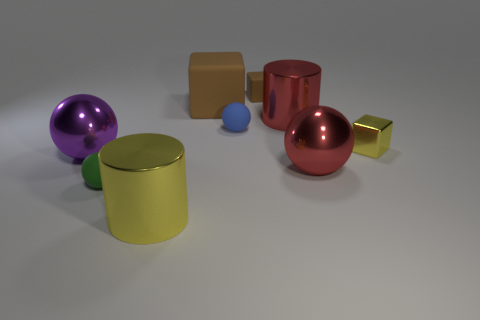What number of small green matte spheres are in front of the small yellow thing?
Keep it short and to the point. 1. The purple shiny object that is the same shape as the green thing is what size?
Make the answer very short. Large. What number of yellow things are either big cylinders or big blocks?
Keep it short and to the point. 1. How many tiny yellow blocks are on the left side of the small ball on the right side of the tiny green matte object?
Offer a terse response. 0. How many other objects are there of the same shape as the tiny blue matte object?
Your answer should be compact. 3. What is the material of the cube that is the same color as the large matte object?
Make the answer very short. Rubber. What number of big metallic cylinders are the same color as the tiny shiny object?
Offer a very short reply. 1. What is the color of the sphere that is the same material as the big purple thing?
Keep it short and to the point. Red. Are there any yellow metallic blocks of the same size as the green ball?
Ensure brevity in your answer.  Yes. Is the number of big red cylinders in front of the big cube greater than the number of blue rubber spheres that are right of the blue matte ball?
Your answer should be compact. Yes. 